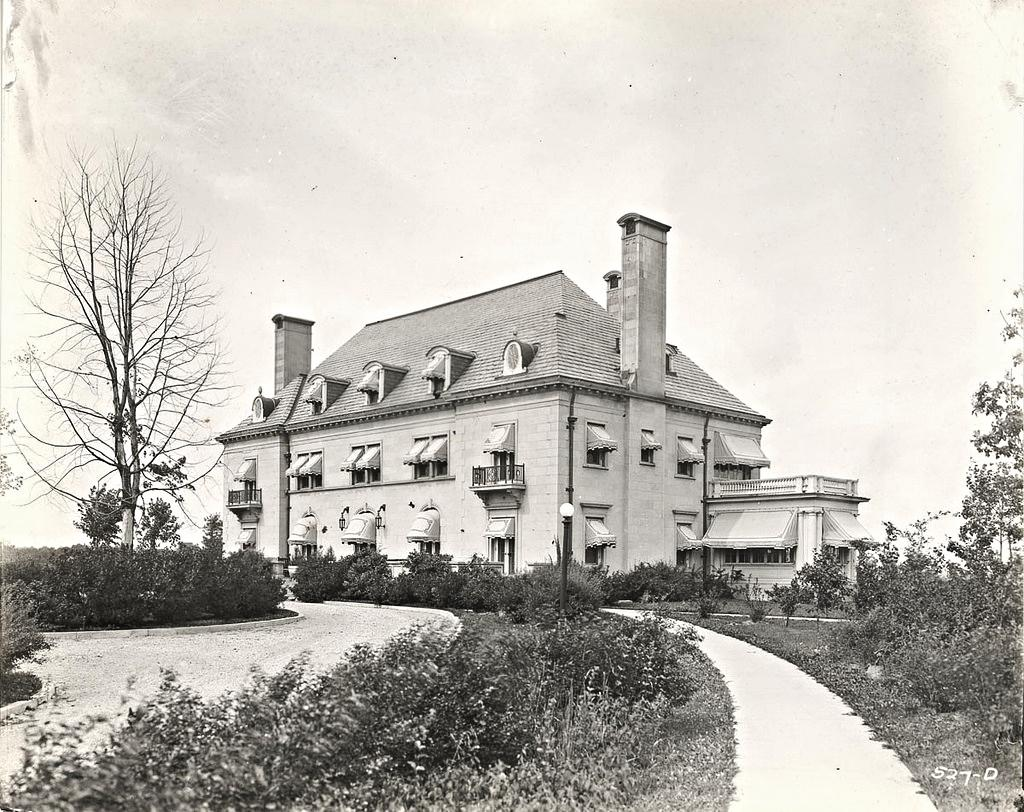What type of structure is visible in the image? There is a building in the image. What can be seen in the foreground of the image? There are trees and plants in the foreground of the image. Is there any indication of a path or way in the image? Yes, there is a way or path in the foreground of the image. What is visible at the top of the image? The sky is visible at the top of the image. What type of paper is being used to create the building in the image? There is no paper used to create the building in the image; it is a real structure. Can you see any fingers in the image? There are no fingers visible in the image. 